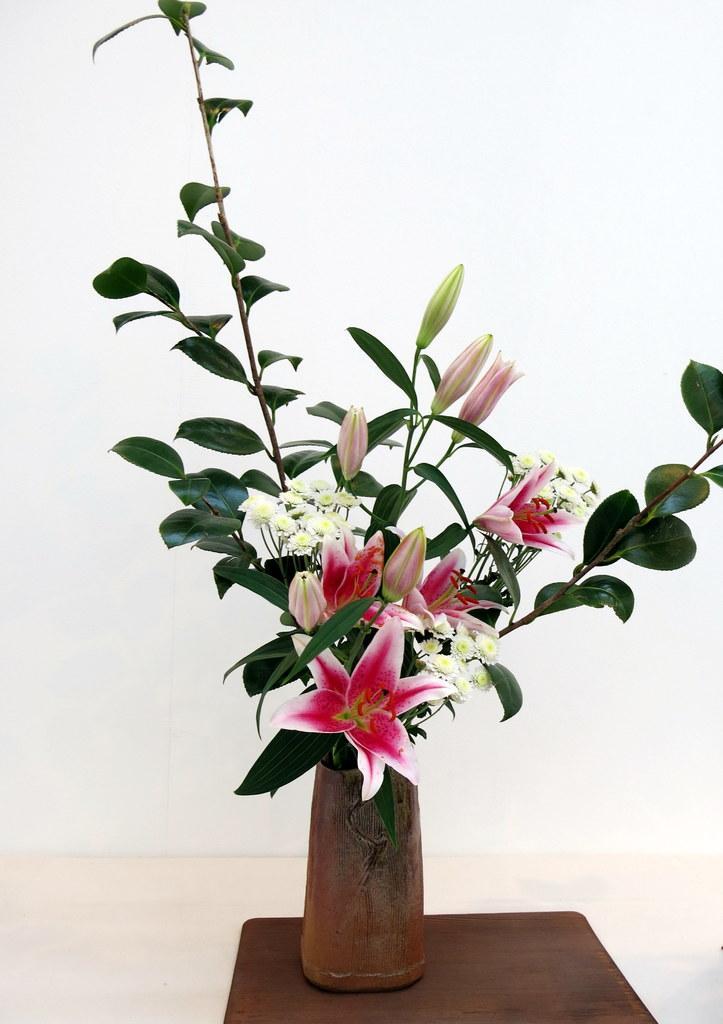In one or two sentences, can you explain what this image depicts? In this image we can see a flower vase placed on the stool. 